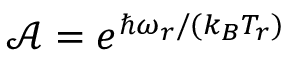<formula> <loc_0><loc_0><loc_500><loc_500>\mathcal { A } = e ^ { \hbar { \omega } _ { r } / ( k _ { B } T _ { r } ) }</formula> 